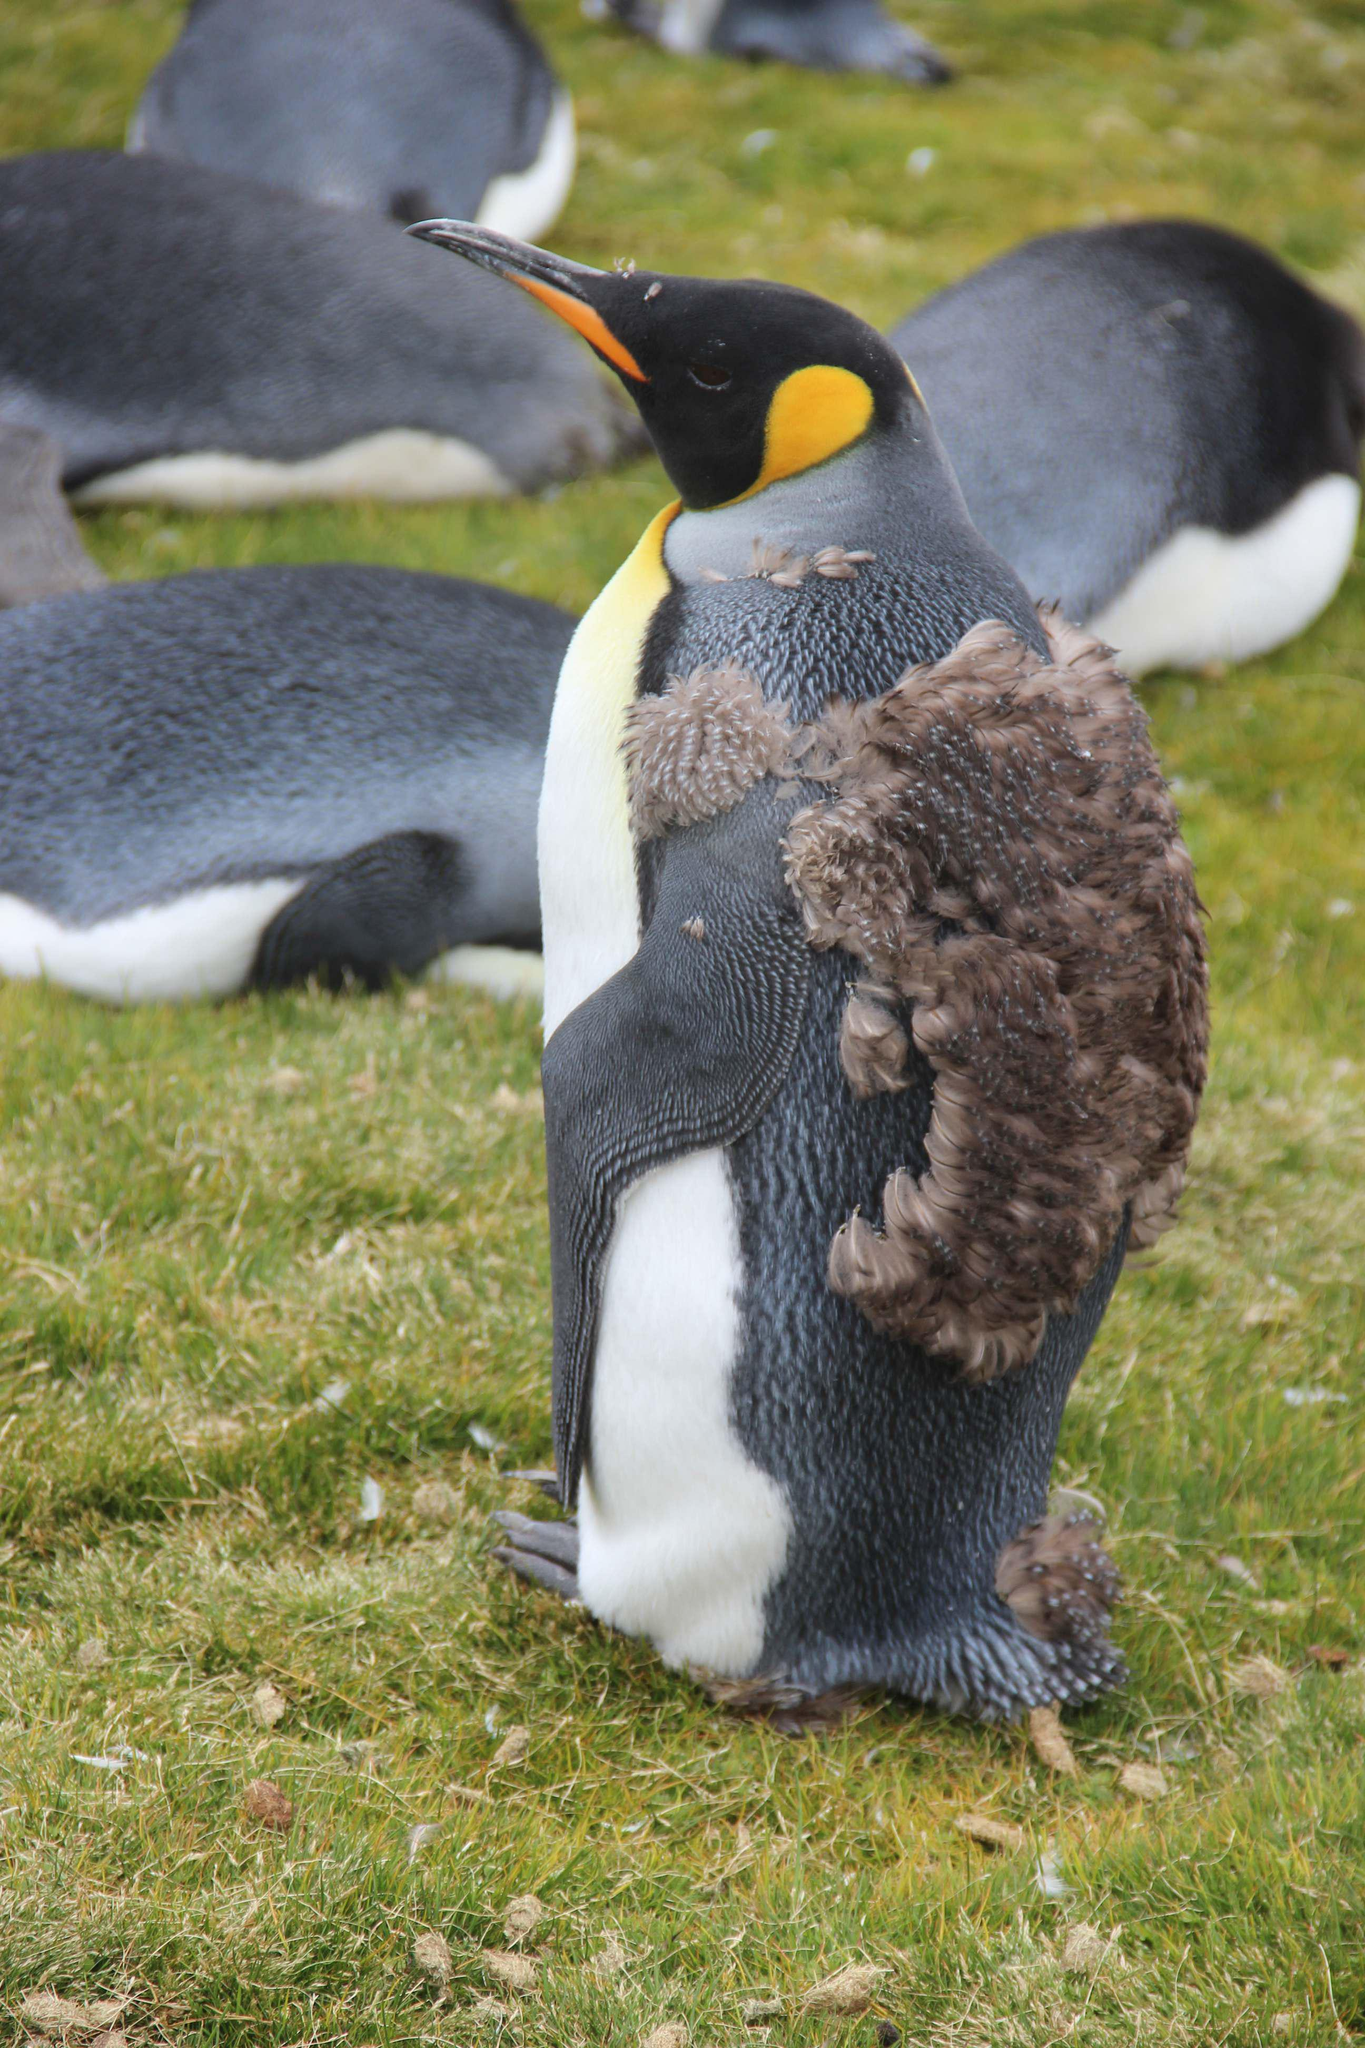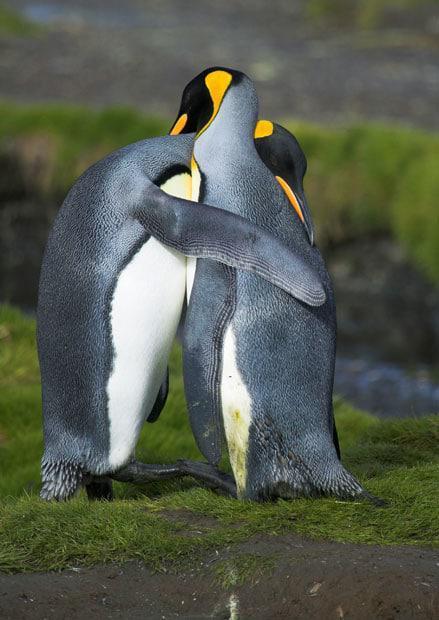The first image is the image on the left, the second image is the image on the right. Examine the images to the left and right. Is the description "An image shows only a moulting penguin with patchy brown feathers." accurate? Answer yes or no. No. The first image is the image on the left, the second image is the image on the right. Considering the images on both sides, is "Two penguins stand together in the image on the right." valid? Answer yes or no. Yes. 